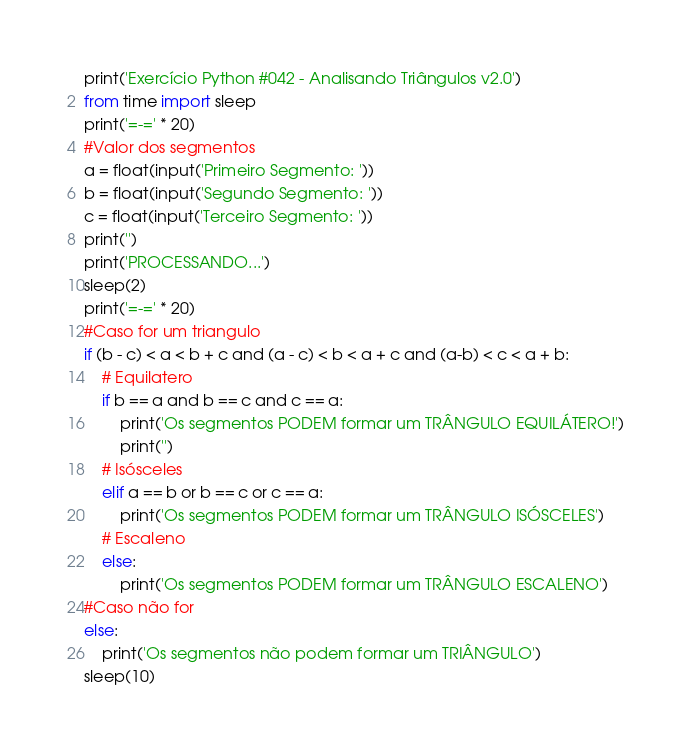Convert code to text. <code><loc_0><loc_0><loc_500><loc_500><_Python_>print('Exercício Python #042 - Analisando Triângulos v2.0')
from time import sleep
print('=-=' * 20)
#Valor dos segmentos
a = float(input('Primeiro Segmento: '))
b = float(input('Segundo Segmento: '))
c = float(input('Terceiro Segmento: '))
print('')
print('PROCESSANDO...')
sleep(2)
print('=-=' * 20)
#Caso for um triangulo
if (b - c) < a < b + c and (a - c) < b < a + c and (a-b) < c < a + b:
    # Equilatero
    if b == a and b == c and c == a:
        print('Os segmentos PODEM formar um TRÂNGULO EQUILÁTERO!')
        print('')
    # Isósceles
    elif a == b or b == c or c == a:
        print('Os segmentos PODEM formar um TRÂNGULO ISÓSCELES')
    # Escaleno
    else:
        print('Os segmentos PODEM formar um TRÂNGULO ESCALENO')
#Caso não for
else:
    print('Os segmentos não podem formar um TRIÂNGULO')
sleep(10)
</code> 